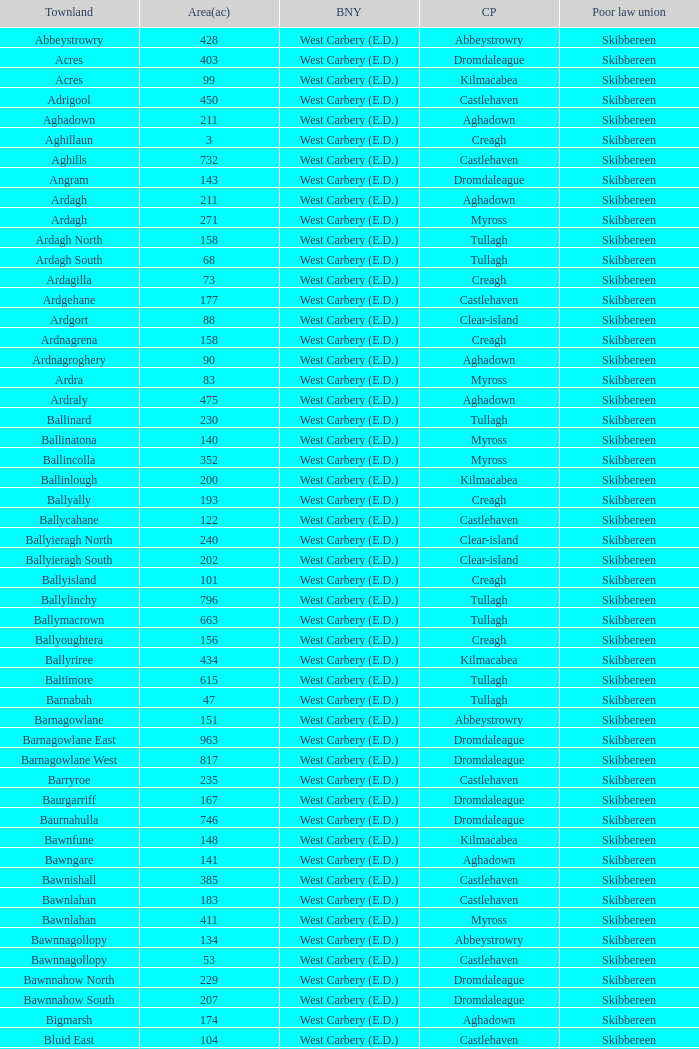What are the civil parishes of the Loughmarsh townland? Aghadown. 